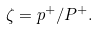<formula> <loc_0><loc_0><loc_500><loc_500>\zeta = p ^ { + } / P ^ { + } .</formula> 